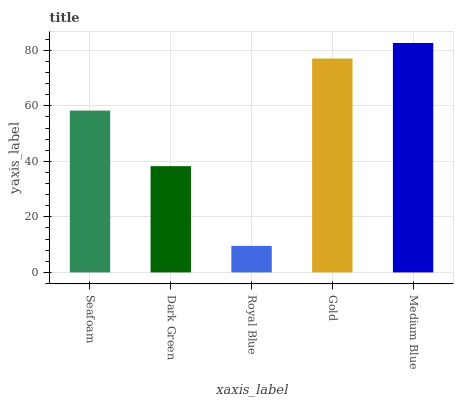Is Royal Blue the minimum?
Answer yes or no. Yes. Is Medium Blue the maximum?
Answer yes or no. Yes. Is Dark Green the minimum?
Answer yes or no. No. Is Dark Green the maximum?
Answer yes or no. No. Is Seafoam greater than Dark Green?
Answer yes or no. Yes. Is Dark Green less than Seafoam?
Answer yes or no. Yes. Is Dark Green greater than Seafoam?
Answer yes or no. No. Is Seafoam less than Dark Green?
Answer yes or no. No. Is Seafoam the high median?
Answer yes or no. Yes. Is Seafoam the low median?
Answer yes or no. Yes. Is Medium Blue the high median?
Answer yes or no. No. Is Gold the low median?
Answer yes or no. No. 